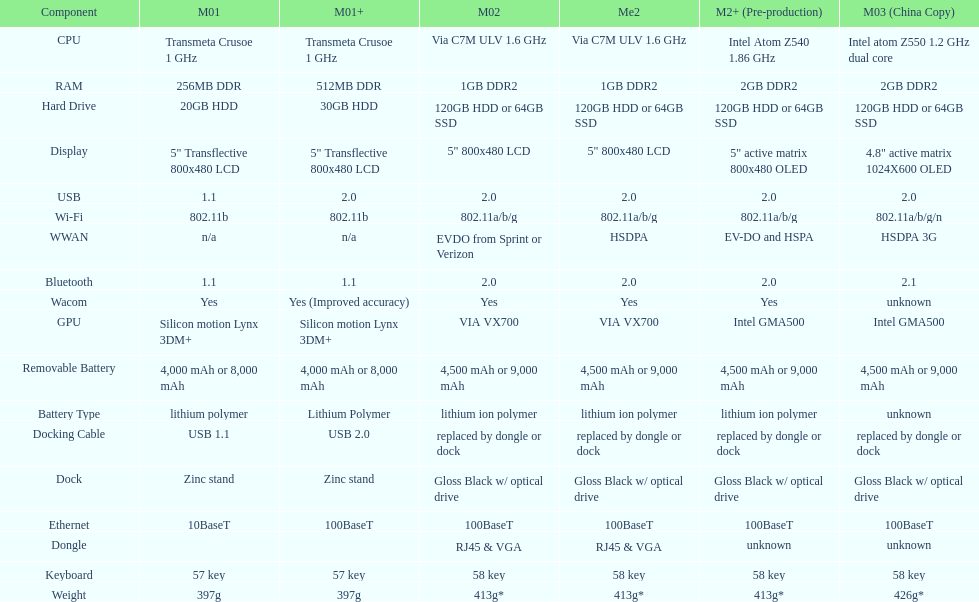What is the average number of models that have usb 2.0? 5. 